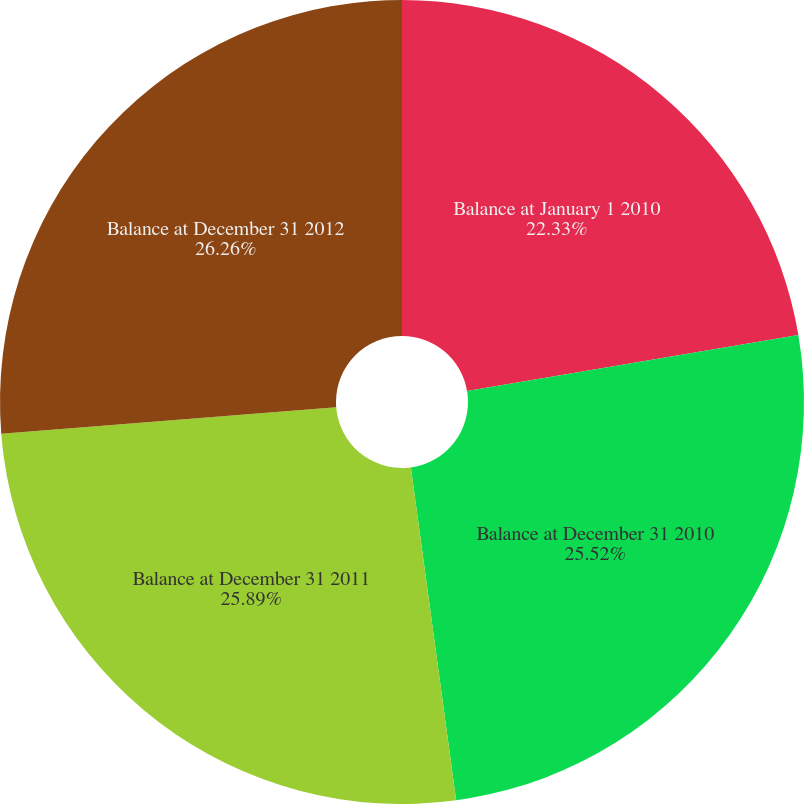Convert chart. <chart><loc_0><loc_0><loc_500><loc_500><pie_chart><fcel>Balance at January 1 2010<fcel>Balance at December 31 2010<fcel>Balance at December 31 2011<fcel>Balance at December 31 2012<nl><fcel>22.33%<fcel>25.52%<fcel>25.89%<fcel>26.26%<nl></chart> 